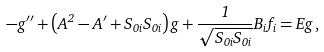<formula> <loc_0><loc_0><loc_500><loc_500>- g ^ { \prime \prime } + \left ( A ^ { 2 } - A ^ { \prime } + S _ { 0 i } S _ { 0 i } \right ) g + \frac { 1 } { \sqrt { S _ { 0 i } S _ { 0 i } } } B _ { i } f _ { i } = E g \, ,</formula> 